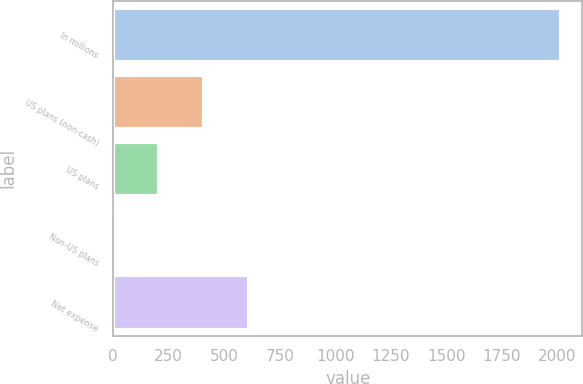<chart> <loc_0><loc_0><loc_500><loc_500><bar_chart><fcel>In millions<fcel>US plans (non-cash)<fcel>US plans<fcel>Non-US plans<fcel>Net expense<nl><fcel>2011<fcel>403.8<fcel>202.9<fcel>2<fcel>604.7<nl></chart> 